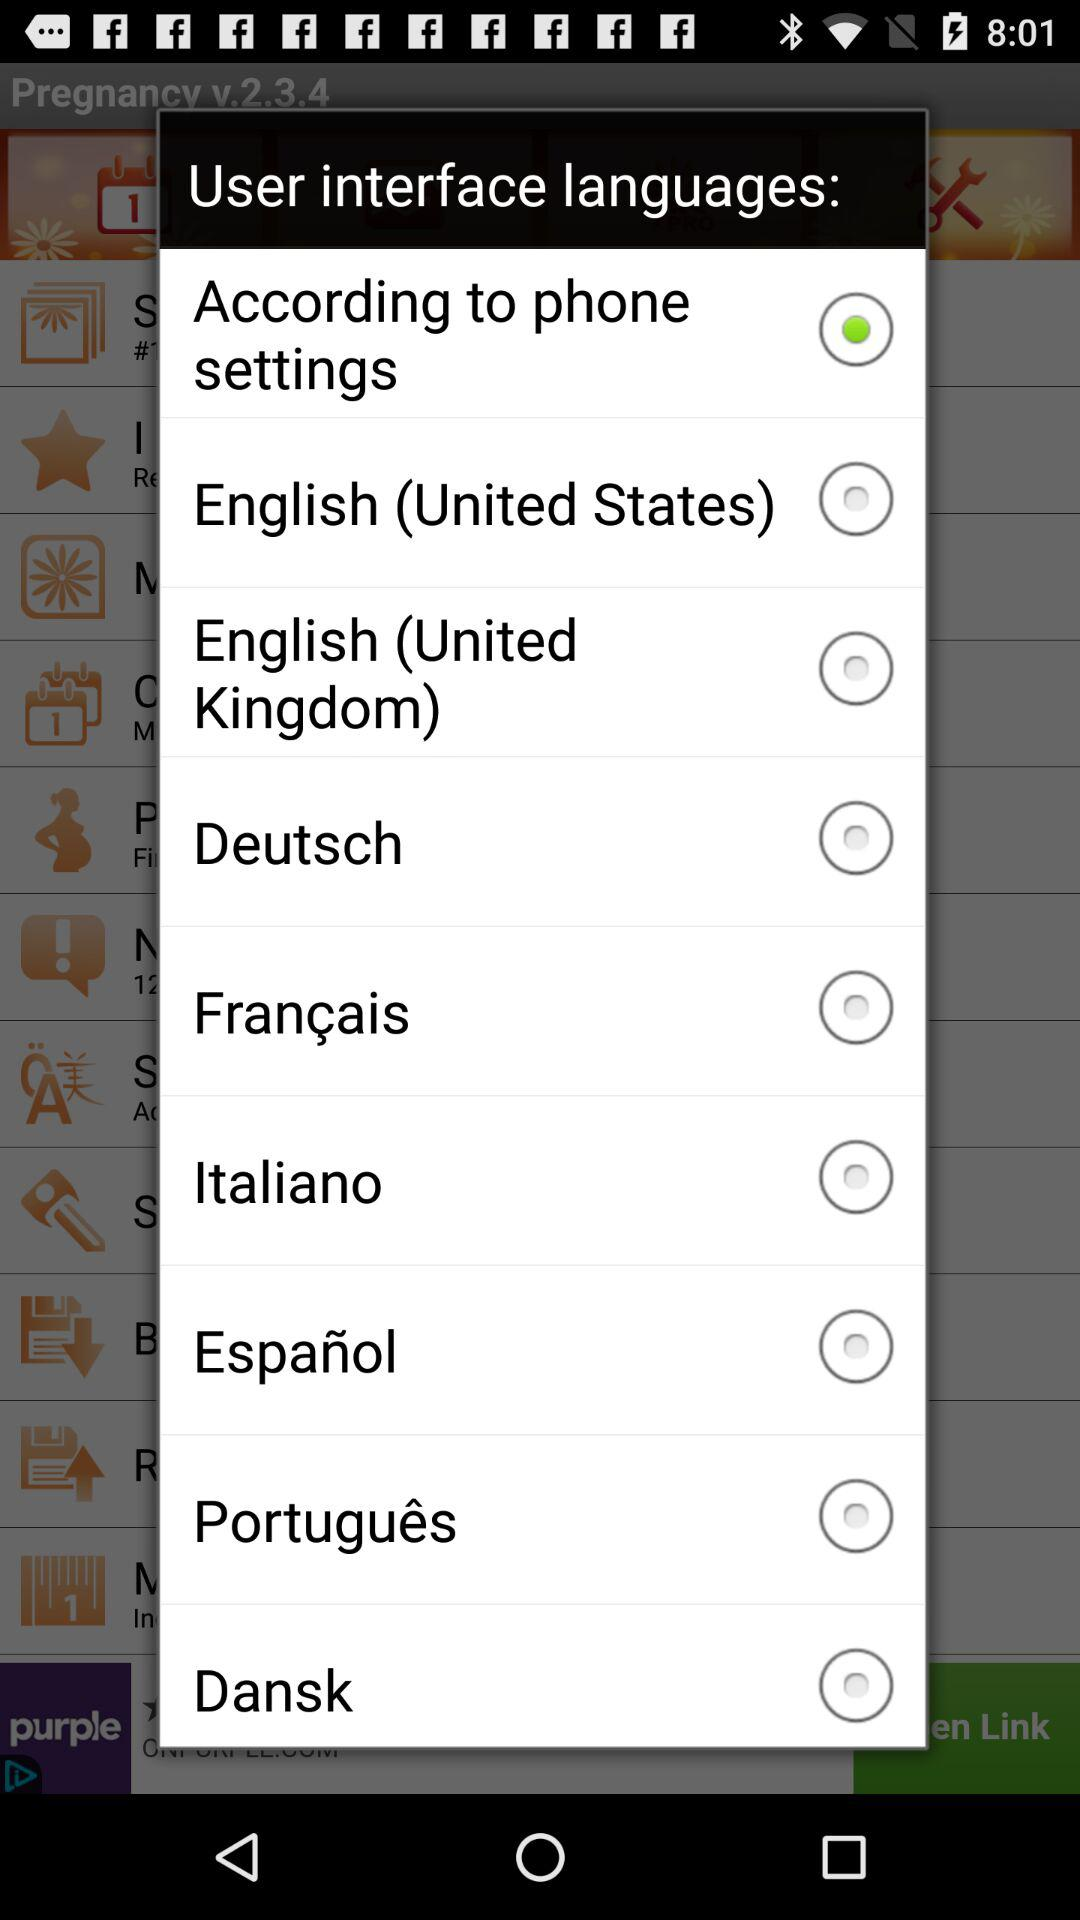What is the name of the application? The name of the application is "Pregnancy". 